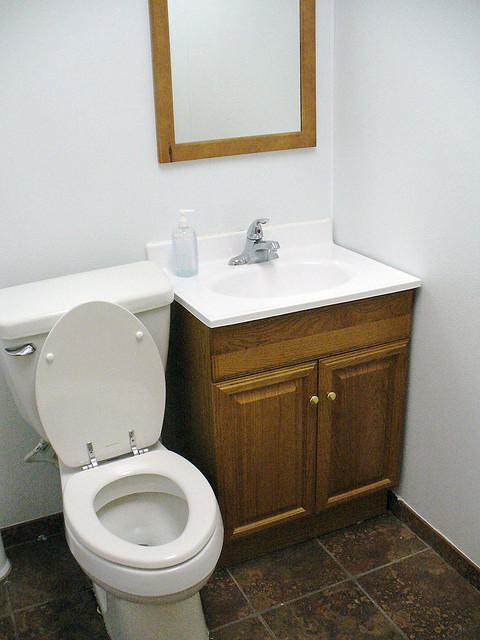Is the lid up or down?
Be succinct. Up. Is anything reflecting in the mirror?
Write a very short answer. No. How can you tell this bathroom is rarely used?
Short answer required. Clean. 